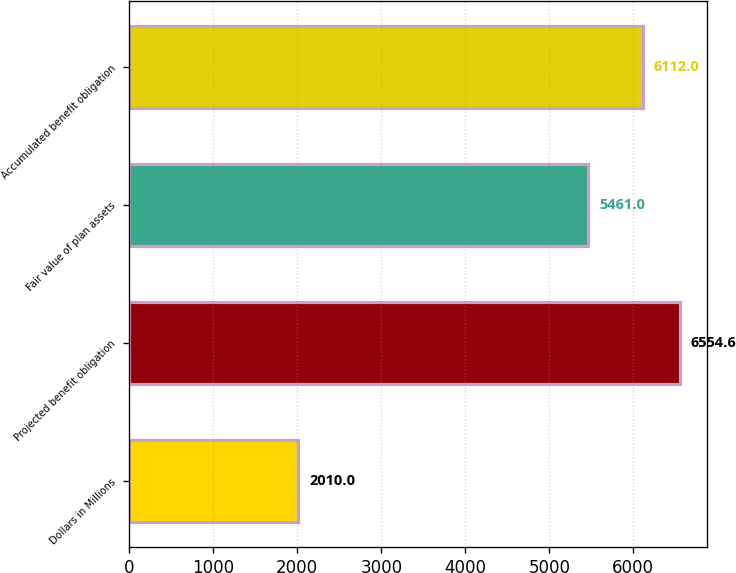Convert chart to OTSL. <chart><loc_0><loc_0><loc_500><loc_500><bar_chart><fcel>Dollars in Millions<fcel>Projected benefit obligation<fcel>Fair value of plan assets<fcel>Accumulated benefit obligation<nl><fcel>2010<fcel>6554.6<fcel>5461<fcel>6112<nl></chart> 